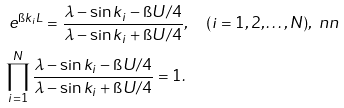Convert formula to latex. <formula><loc_0><loc_0><loc_500><loc_500>& \ e ^ { \i k _ { i } L } = \frac { \lambda - \sin k _ { i } - \i U / 4 } { \lambda - \sin k _ { i } + \i U / 4 } , \quad ( i = 1 , 2 , \dots , N ) , \ n n \\ & \prod _ { i = 1 } ^ { N } \frac { \lambda - \sin k _ { i } - \i U / 4 } { \lambda - \sin k _ { i } + \i U / 4 } = 1 .</formula> 